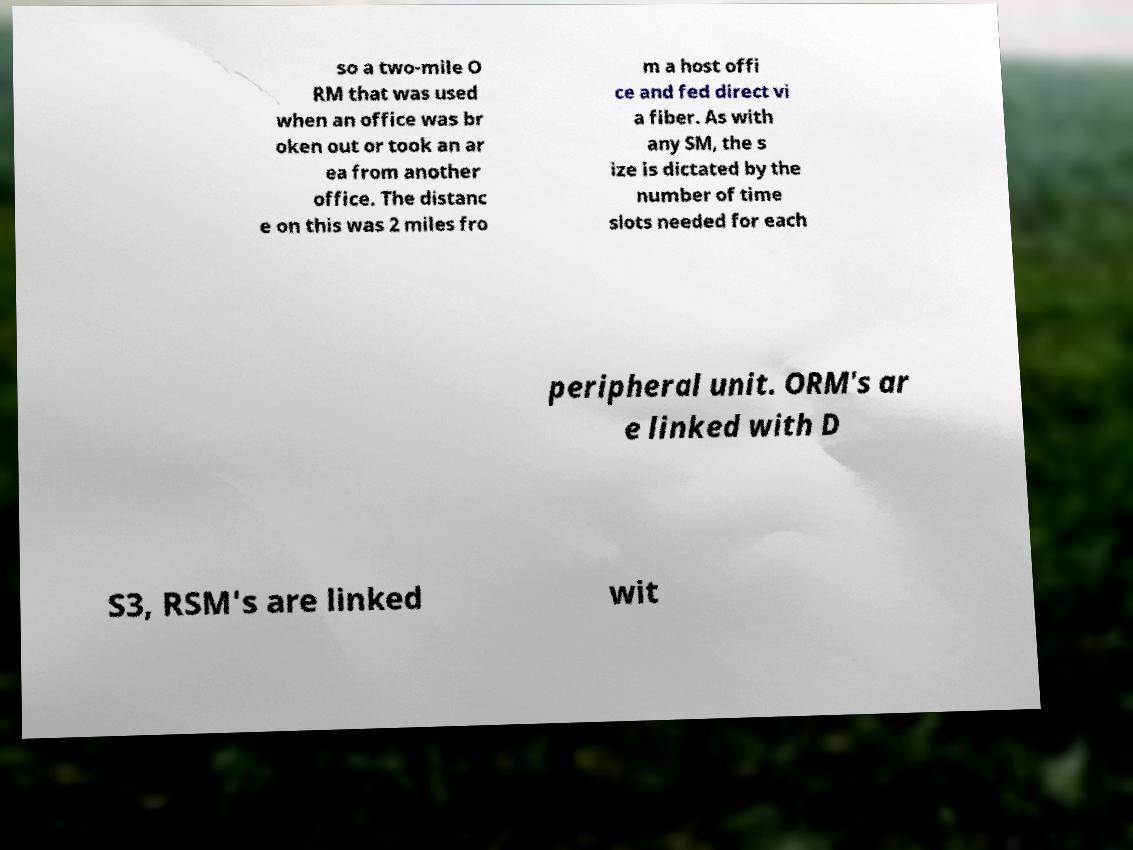Please read and relay the text visible in this image. What does it say? so a two-mile O RM that was used when an office was br oken out or took an ar ea from another office. The distanc e on this was 2 miles fro m a host offi ce and fed direct vi a fiber. As with any SM, the s ize is dictated by the number of time slots needed for each peripheral unit. ORM's ar e linked with D S3, RSM's are linked wit 